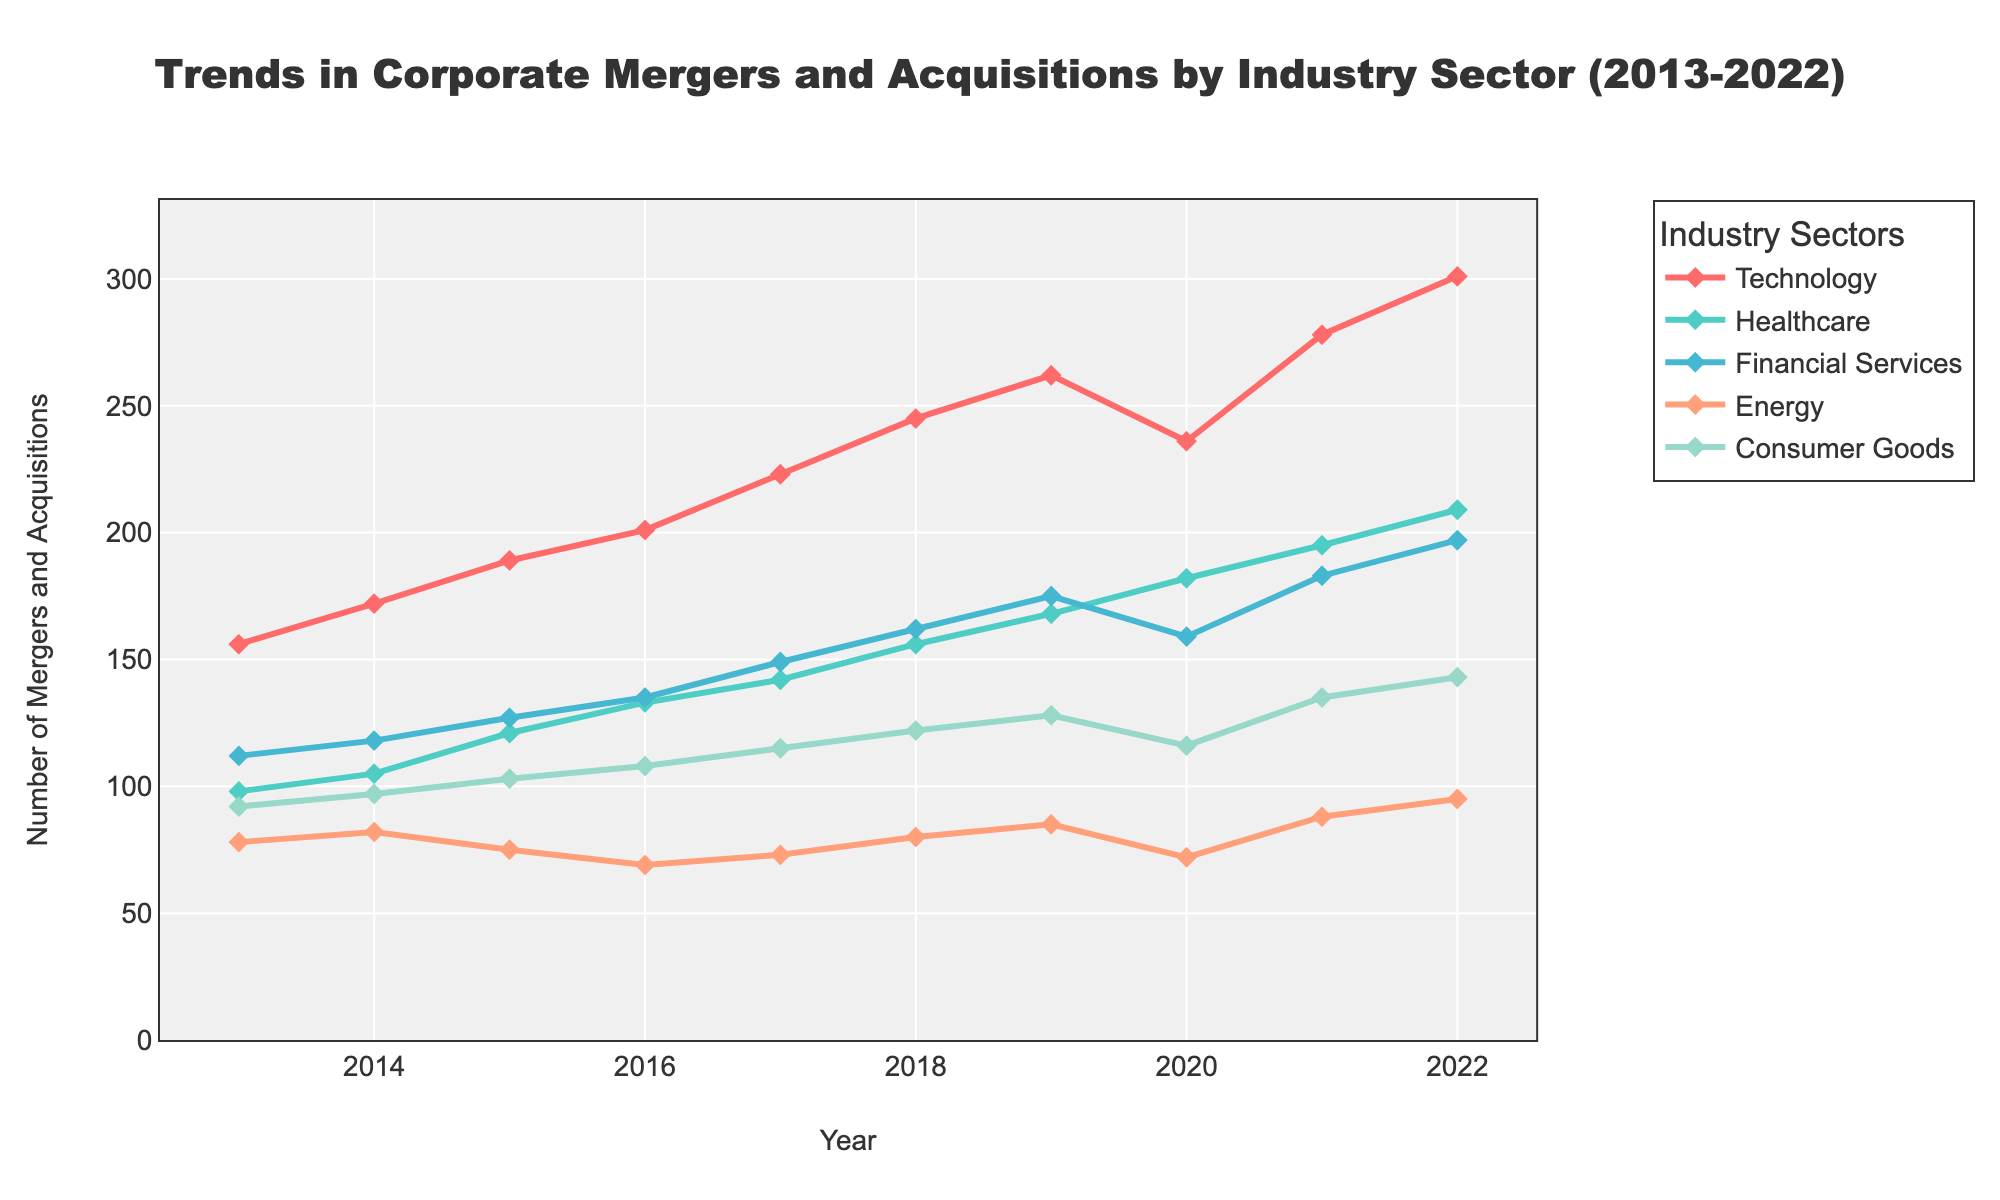What's the overall trend in mergers and acquisitions in the Technology sector from 2013 to 2022? The trend in the Technology sector shows a consistent increase in the number of mergers and acquisitions over the years from 156 in 2013 to 301 in 2022, illustrating growth in this sector.
Answer: Increasing Which year saw the highest number of mergers and acquisitions in the Healthcare sector? By examining the peaks in the Healthcare sector line, the highest point is at 209 in the year 2022.
Answer: 2022 Between the Energy and Financial Services sectors, which one had more mergers and acquisitions in 2016, and by how much? The Energy sector had 69 mergers and acquisitions, while the Financial Services sector had 135 in 2016. The difference is 135 - 69 = 66.
Answer: Financial Services by 66 What is the average number of mergers and acquisitions in the Consumer Goods sector over the decade? Sum the number of mergers and acquisitions in the Consumer Goods sector from 2013 to 2022: 92 + 97 + 103 + 108 + 115 + 122 + 128 + 116 + 135 + 143 = 1159. There are 10 years, so the average is 1159/10 = 115.9.
Answer: 115.9 Which sector had the biggest increase in the number of mergers and acquisitions from 2013 to 2022? Calculate the difference in the number of mergers and acquisitions for each sector between 2022 and 2013: Technology (301-156=145), Healthcare (209-98=111), Financial Services (197-112=85), Energy (95-78=17), Consumer Goods (143-92=51). The Technology sector had the largest increase, with a difference of 145.
Answer: Technology In 2020, did the number of mergers and acquisitions in the Technology sector increase or decrease compared to 2019, and by how much? The Technology sector had 262 mergers in 2019 and 236 in 2020. The difference is 236 - 262 = -26, indicating a decrease.
Answer: Decrease by 26 What is the trend in the Energy sector over the decade? The Energy sector shows fluctuations but generally a slight decrease from 78 mergers and acquisitions in 2013 to 95 in 2022, with the most notable dip to 69 in 2016.
Answer: Slightly decreasing How did the mergers and acquisitions in Financial Services compare to Healthcare in 2021? In 2021, Financial Services had 183 mergers and acquisitions, while Healthcare had 195. The difference is 195 - 183 = 12, meaning Healthcare had more by 12.
Answer: Healthcare by 12 Which two sectors had the closest number of mergers and acquisitions in 2015? In 2015, the numbers are: Technology (189), Healthcare (121), Financial Services (127), Energy (75), Consumer Goods (103). The closest numbers are Healthcare (121) and Consumer Goods (103) with a difference of 121 - 103 = 18.
Answer: Healthcare and Consumer Goods Are there any sectors where the trend in mergers and acquisitions shows a significant drop in any particular year? The Technology sector shows a significant drop from 262 in 2019 to 236 in 2020, indicating a significant decrease.
Answer: Technology in 2020 